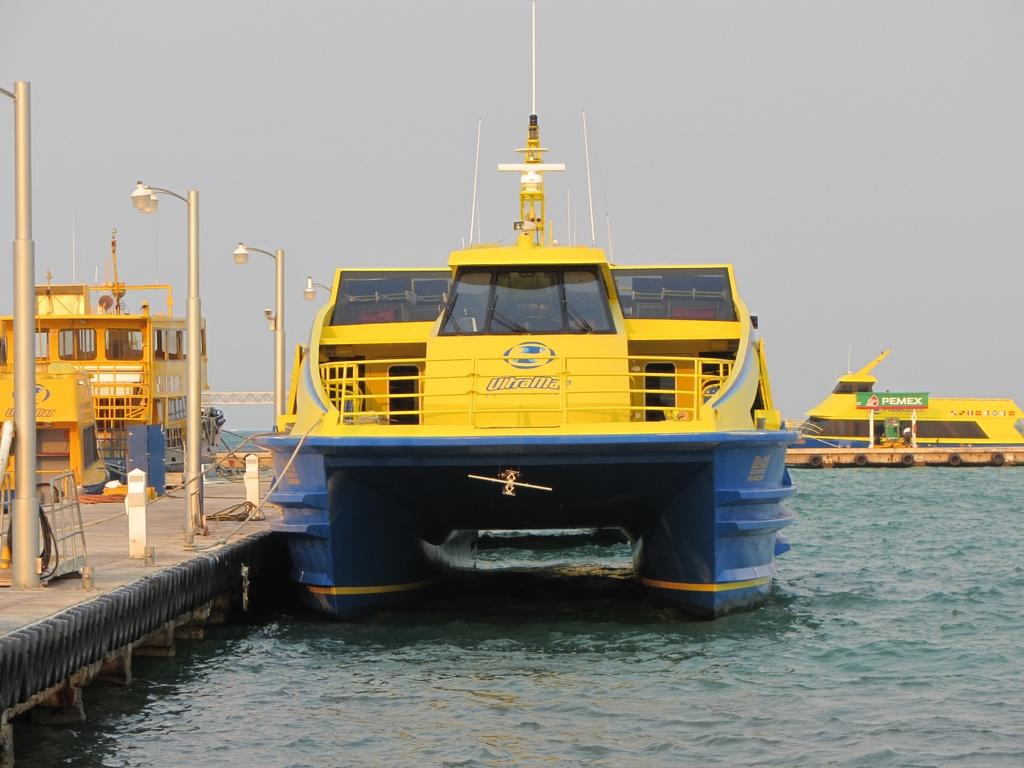What is in the water in the image? There are boats in the water in the image. What can be seen on the left side of the image? There are street lights and objects on the pathway on the left side of the image. What is visible in the background of the image? The sky is visible in the background of the image. Where is the sweater located in the image? There is no sweater present in the image. What type of dock can be seen in the image? There is no dock present in the image. 